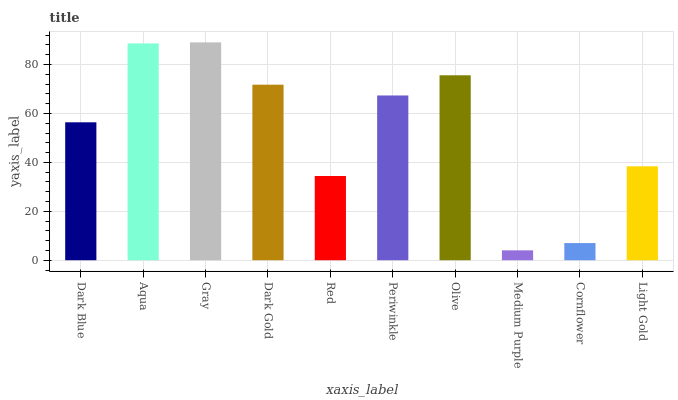Is Aqua the minimum?
Answer yes or no. No. Is Aqua the maximum?
Answer yes or no. No. Is Aqua greater than Dark Blue?
Answer yes or no. Yes. Is Dark Blue less than Aqua?
Answer yes or no. Yes. Is Dark Blue greater than Aqua?
Answer yes or no. No. Is Aqua less than Dark Blue?
Answer yes or no. No. Is Periwinkle the high median?
Answer yes or no. Yes. Is Dark Blue the low median?
Answer yes or no. Yes. Is Medium Purple the high median?
Answer yes or no. No. Is Cornflower the low median?
Answer yes or no. No. 